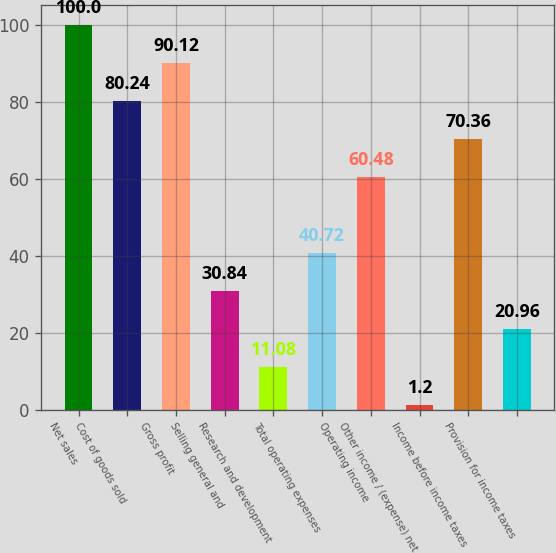<chart> <loc_0><loc_0><loc_500><loc_500><bar_chart><fcel>Net sales<fcel>Cost of goods sold<fcel>Gross profit<fcel>Selling general and<fcel>Research and development<fcel>Total operating expenses<fcel>Operating income<fcel>Other income / (expense) net<fcel>Income before income taxes<fcel>Provision for income taxes<nl><fcel>100<fcel>80.24<fcel>90.12<fcel>30.84<fcel>11.08<fcel>40.72<fcel>60.48<fcel>1.2<fcel>70.36<fcel>20.96<nl></chart> 